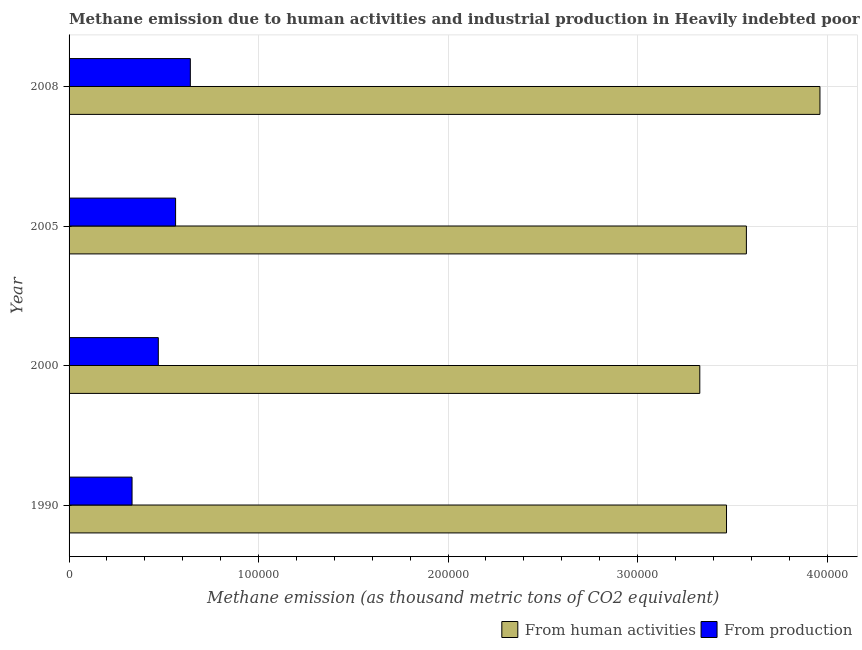How many groups of bars are there?
Make the answer very short. 4. Are the number of bars per tick equal to the number of legend labels?
Give a very brief answer. Yes. Are the number of bars on each tick of the Y-axis equal?
Your answer should be compact. Yes. How many bars are there on the 2nd tick from the bottom?
Your answer should be very brief. 2. What is the label of the 4th group of bars from the top?
Your answer should be compact. 1990. What is the amount of emissions from human activities in 2005?
Your answer should be very brief. 3.57e+05. Across all years, what is the maximum amount of emissions generated from industries?
Your answer should be compact. 6.40e+04. Across all years, what is the minimum amount of emissions generated from industries?
Keep it short and to the point. 3.32e+04. What is the total amount of emissions from human activities in the graph?
Ensure brevity in your answer.  1.43e+06. What is the difference between the amount of emissions generated from industries in 1990 and that in 2005?
Provide a short and direct response. -2.30e+04. What is the difference between the amount of emissions generated from industries in 2008 and the amount of emissions from human activities in 1990?
Your answer should be very brief. -2.83e+05. What is the average amount of emissions generated from industries per year?
Your answer should be compact. 5.01e+04. In the year 2005, what is the difference between the amount of emissions from human activities and amount of emissions generated from industries?
Give a very brief answer. 3.01e+05. What is the ratio of the amount of emissions from human activities in 2005 to that in 2008?
Your answer should be very brief. 0.9. Is the difference between the amount of emissions generated from industries in 2000 and 2005 greater than the difference between the amount of emissions from human activities in 2000 and 2005?
Your response must be concise. Yes. What is the difference between the highest and the second highest amount of emissions generated from industries?
Provide a short and direct response. 7773.4. What is the difference between the highest and the lowest amount of emissions from human activities?
Provide a succinct answer. 6.34e+04. Is the sum of the amount of emissions generated from industries in 2005 and 2008 greater than the maximum amount of emissions from human activities across all years?
Offer a terse response. No. What does the 1st bar from the top in 2005 represents?
Provide a short and direct response. From production. What does the 2nd bar from the bottom in 1990 represents?
Offer a terse response. From production. How many bars are there?
Your response must be concise. 8. What is the difference between two consecutive major ticks on the X-axis?
Ensure brevity in your answer.  1.00e+05. Are the values on the major ticks of X-axis written in scientific E-notation?
Offer a very short reply. No. Does the graph contain grids?
Give a very brief answer. Yes. How many legend labels are there?
Provide a succinct answer. 2. How are the legend labels stacked?
Provide a short and direct response. Horizontal. What is the title of the graph?
Offer a very short reply. Methane emission due to human activities and industrial production in Heavily indebted poor countries. Does "Rural" appear as one of the legend labels in the graph?
Provide a succinct answer. No. What is the label or title of the X-axis?
Offer a very short reply. Methane emission (as thousand metric tons of CO2 equivalent). What is the Methane emission (as thousand metric tons of CO2 equivalent) in From human activities in 1990?
Make the answer very short. 3.47e+05. What is the Methane emission (as thousand metric tons of CO2 equivalent) of From production in 1990?
Provide a short and direct response. 3.32e+04. What is the Methane emission (as thousand metric tons of CO2 equivalent) in From human activities in 2000?
Give a very brief answer. 3.33e+05. What is the Methane emission (as thousand metric tons of CO2 equivalent) of From production in 2000?
Keep it short and to the point. 4.71e+04. What is the Methane emission (as thousand metric tons of CO2 equivalent) in From human activities in 2005?
Provide a succinct answer. 3.57e+05. What is the Methane emission (as thousand metric tons of CO2 equivalent) in From production in 2005?
Make the answer very short. 5.62e+04. What is the Methane emission (as thousand metric tons of CO2 equivalent) of From human activities in 2008?
Keep it short and to the point. 3.96e+05. What is the Methane emission (as thousand metric tons of CO2 equivalent) in From production in 2008?
Your response must be concise. 6.40e+04. Across all years, what is the maximum Methane emission (as thousand metric tons of CO2 equivalent) of From human activities?
Make the answer very short. 3.96e+05. Across all years, what is the maximum Methane emission (as thousand metric tons of CO2 equivalent) of From production?
Make the answer very short. 6.40e+04. Across all years, what is the minimum Methane emission (as thousand metric tons of CO2 equivalent) in From human activities?
Make the answer very short. 3.33e+05. Across all years, what is the minimum Methane emission (as thousand metric tons of CO2 equivalent) in From production?
Your answer should be very brief. 3.32e+04. What is the total Methane emission (as thousand metric tons of CO2 equivalent) of From human activities in the graph?
Your answer should be very brief. 1.43e+06. What is the total Methane emission (as thousand metric tons of CO2 equivalent) in From production in the graph?
Provide a short and direct response. 2.01e+05. What is the difference between the Methane emission (as thousand metric tons of CO2 equivalent) in From human activities in 1990 and that in 2000?
Give a very brief answer. 1.41e+04. What is the difference between the Methane emission (as thousand metric tons of CO2 equivalent) of From production in 1990 and that in 2000?
Your response must be concise. -1.39e+04. What is the difference between the Methane emission (as thousand metric tons of CO2 equivalent) of From human activities in 1990 and that in 2005?
Make the answer very short. -1.05e+04. What is the difference between the Methane emission (as thousand metric tons of CO2 equivalent) of From production in 1990 and that in 2005?
Provide a short and direct response. -2.30e+04. What is the difference between the Methane emission (as thousand metric tons of CO2 equivalent) in From human activities in 1990 and that in 2008?
Provide a succinct answer. -4.93e+04. What is the difference between the Methane emission (as thousand metric tons of CO2 equivalent) of From production in 1990 and that in 2008?
Provide a succinct answer. -3.08e+04. What is the difference between the Methane emission (as thousand metric tons of CO2 equivalent) of From human activities in 2000 and that in 2005?
Make the answer very short. -2.46e+04. What is the difference between the Methane emission (as thousand metric tons of CO2 equivalent) in From production in 2000 and that in 2005?
Offer a terse response. -9122.4. What is the difference between the Methane emission (as thousand metric tons of CO2 equivalent) of From human activities in 2000 and that in 2008?
Your response must be concise. -6.34e+04. What is the difference between the Methane emission (as thousand metric tons of CO2 equivalent) in From production in 2000 and that in 2008?
Your answer should be compact. -1.69e+04. What is the difference between the Methane emission (as thousand metric tons of CO2 equivalent) of From human activities in 2005 and that in 2008?
Keep it short and to the point. -3.88e+04. What is the difference between the Methane emission (as thousand metric tons of CO2 equivalent) in From production in 2005 and that in 2008?
Give a very brief answer. -7773.4. What is the difference between the Methane emission (as thousand metric tons of CO2 equivalent) of From human activities in 1990 and the Methane emission (as thousand metric tons of CO2 equivalent) of From production in 2000?
Make the answer very short. 3.00e+05. What is the difference between the Methane emission (as thousand metric tons of CO2 equivalent) of From human activities in 1990 and the Methane emission (as thousand metric tons of CO2 equivalent) of From production in 2005?
Your answer should be compact. 2.91e+05. What is the difference between the Methane emission (as thousand metric tons of CO2 equivalent) of From human activities in 1990 and the Methane emission (as thousand metric tons of CO2 equivalent) of From production in 2008?
Offer a terse response. 2.83e+05. What is the difference between the Methane emission (as thousand metric tons of CO2 equivalent) in From human activities in 2000 and the Methane emission (as thousand metric tons of CO2 equivalent) in From production in 2005?
Offer a very short reply. 2.77e+05. What is the difference between the Methane emission (as thousand metric tons of CO2 equivalent) of From human activities in 2000 and the Methane emission (as thousand metric tons of CO2 equivalent) of From production in 2008?
Provide a short and direct response. 2.69e+05. What is the difference between the Methane emission (as thousand metric tons of CO2 equivalent) in From human activities in 2005 and the Methane emission (as thousand metric tons of CO2 equivalent) in From production in 2008?
Provide a short and direct response. 2.93e+05. What is the average Methane emission (as thousand metric tons of CO2 equivalent) of From human activities per year?
Provide a succinct answer. 3.58e+05. What is the average Methane emission (as thousand metric tons of CO2 equivalent) in From production per year?
Offer a very short reply. 5.01e+04. In the year 1990, what is the difference between the Methane emission (as thousand metric tons of CO2 equivalent) of From human activities and Methane emission (as thousand metric tons of CO2 equivalent) of From production?
Give a very brief answer. 3.14e+05. In the year 2000, what is the difference between the Methane emission (as thousand metric tons of CO2 equivalent) of From human activities and Methane emission (as thousand metric tons of CO2 equivalent) of From production?
Make the answer very short. 2.86e+05. In the year 2005, what is the difference between the Methane emission (as thousand metric tons of CO2 equivalent) in From human activities and Methane emission (as thousand metric tons of CO2 equivalent) in From production?
Your answer should be compact. 3.01e+05. In the year 2008, what is the difference between the Methane emission (as thousand metric tons of CO2 equivalent) of From human activities and Methane emission (as thousand metric tons of CO2 equivalent) of From production?
Your answer should be very brief. 3.32e+05. What is the ratio of the Methane emission (as thousand metric tons of CO2 equivalent) of From human activities in 1990 to that in 2000?
Offer a very short reply. 1.04. What is the ratio of the Methane emission (as thousand metric tons of CO2 equivalent) of From production in 1990 to that in 2000?
Provide a succinct answer. 0.71. What is the ratio of the Methane emission (as thousand metric tons of CO2 equivalent) of From human activities in 1990 to that in 2005?
Give a very brief answer. 0.97. What is the ratio of the Methane emission (as thousand metric tons of CO2 equivalent) in From production in 1990 to that in 2005?
Provide a short and direct response. 0.59. What is the ratio of the Methane emission (as thousand metric tons of CO2 equivalent) in From human activities in 1990 to that in 2008?
Offer a very short reply. 0.88. What is the ratio of the Methane emission (as thousand metric tons of CO2 equivalent) of From production in 1990 to that in 2008?
Keep it short and to the point. 0.52. What is the ratio of the Methane emission (as thousand metric tons of CO2 equivalent) of From human activities in 2000 to that in 2005?
Give a very brief answer. 0.93. What is the ratio of the Methane emission (as thousand metric tons of CO2 equivalent) of From production in 2000 to that in 2005?
Offer a terse response. 0.84. What is the ratio of the Methane emission (as thousand metric tons of CO2 equivalent) in From human activities in 2000 to that in 2008?
Keep it short and to the point. 0.84. What is the ratio of the Methane emission (as thousand metric tons of CO2 equivalent) in From production in 2000 to that in 2008?
Offer a terse response. 0.74. What is the ratio of the Methane emission (as thousand metric tons of CO2 equivalent) in From human activities in 2005 to that in 2008?
Your answer should be very brief. 0.9. What is the ratio of the Methane emission (as thousand metric tons of CO2 equivalent) in From production in 2005 to that in 2008?
Your answer should be very brief. 0.88. What is the difference between the highest and the second highest Methane emission (as thousand metric tons of CO2 equivalent) of From human activities?
Offer a very short reply. 3.88e+04. What is the difference between the highest and the second highest Methane emission (as thousand metric tons of CO2 equivalent) of From production?
Make the answer very short. 7773.4. What is the difference between the highest and the lowest Methane emission (as thousand metric tons of CO2 equivalent) in From human activities?
Your response must be concise. 6.34e+04. What is the difference between the highest and the lowest Methane emission (as thousand metric tons of CO2 equivalent) in From production?
Provide a short and direct response. 3.08e+04. 